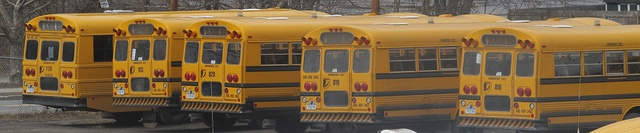Describe the objects in this image and their specific colors. I can see bus in gray, olive, orange, and tan tones, bus in gray, olive, brown, and orange tones, bus in gray, black, olive, tan, and maroon tones, bus in gray, olive, black, maroon, and orange tones, and bus in gray, olive, orange, and black tones in this image. 